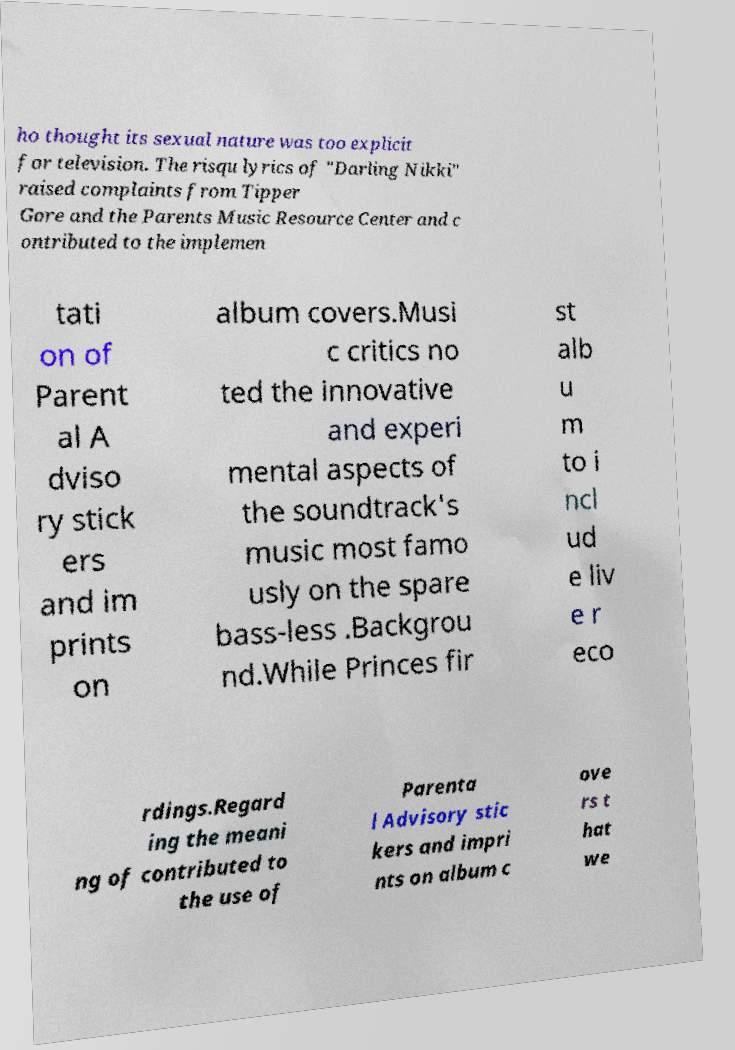Can you read and provide the text displayed in the image?This photo seems to have some interesting text. Can you extract and type it out for me? ho thought its sexual nature was too explicit for television. The risqu lyrics of "Darling Nikki" raised complaints from Tipper Gore and the Parents Music Resource Center and c ontributed to the implemen tati on of Parent al A dviso ry stick ers and im prints on album covers.Musi c critics no ted the innovative and experi mental aspects of the soundtrack's music most famo usly on the spare bass-less .Backgrou nd.While Princes fir st alb u m to i ncl ud e liv e r eco rdings.Regard ing the meani ng of contributed to the use of Parenta l Advisory stic kers and impri nts on album c ove rs t hat we 